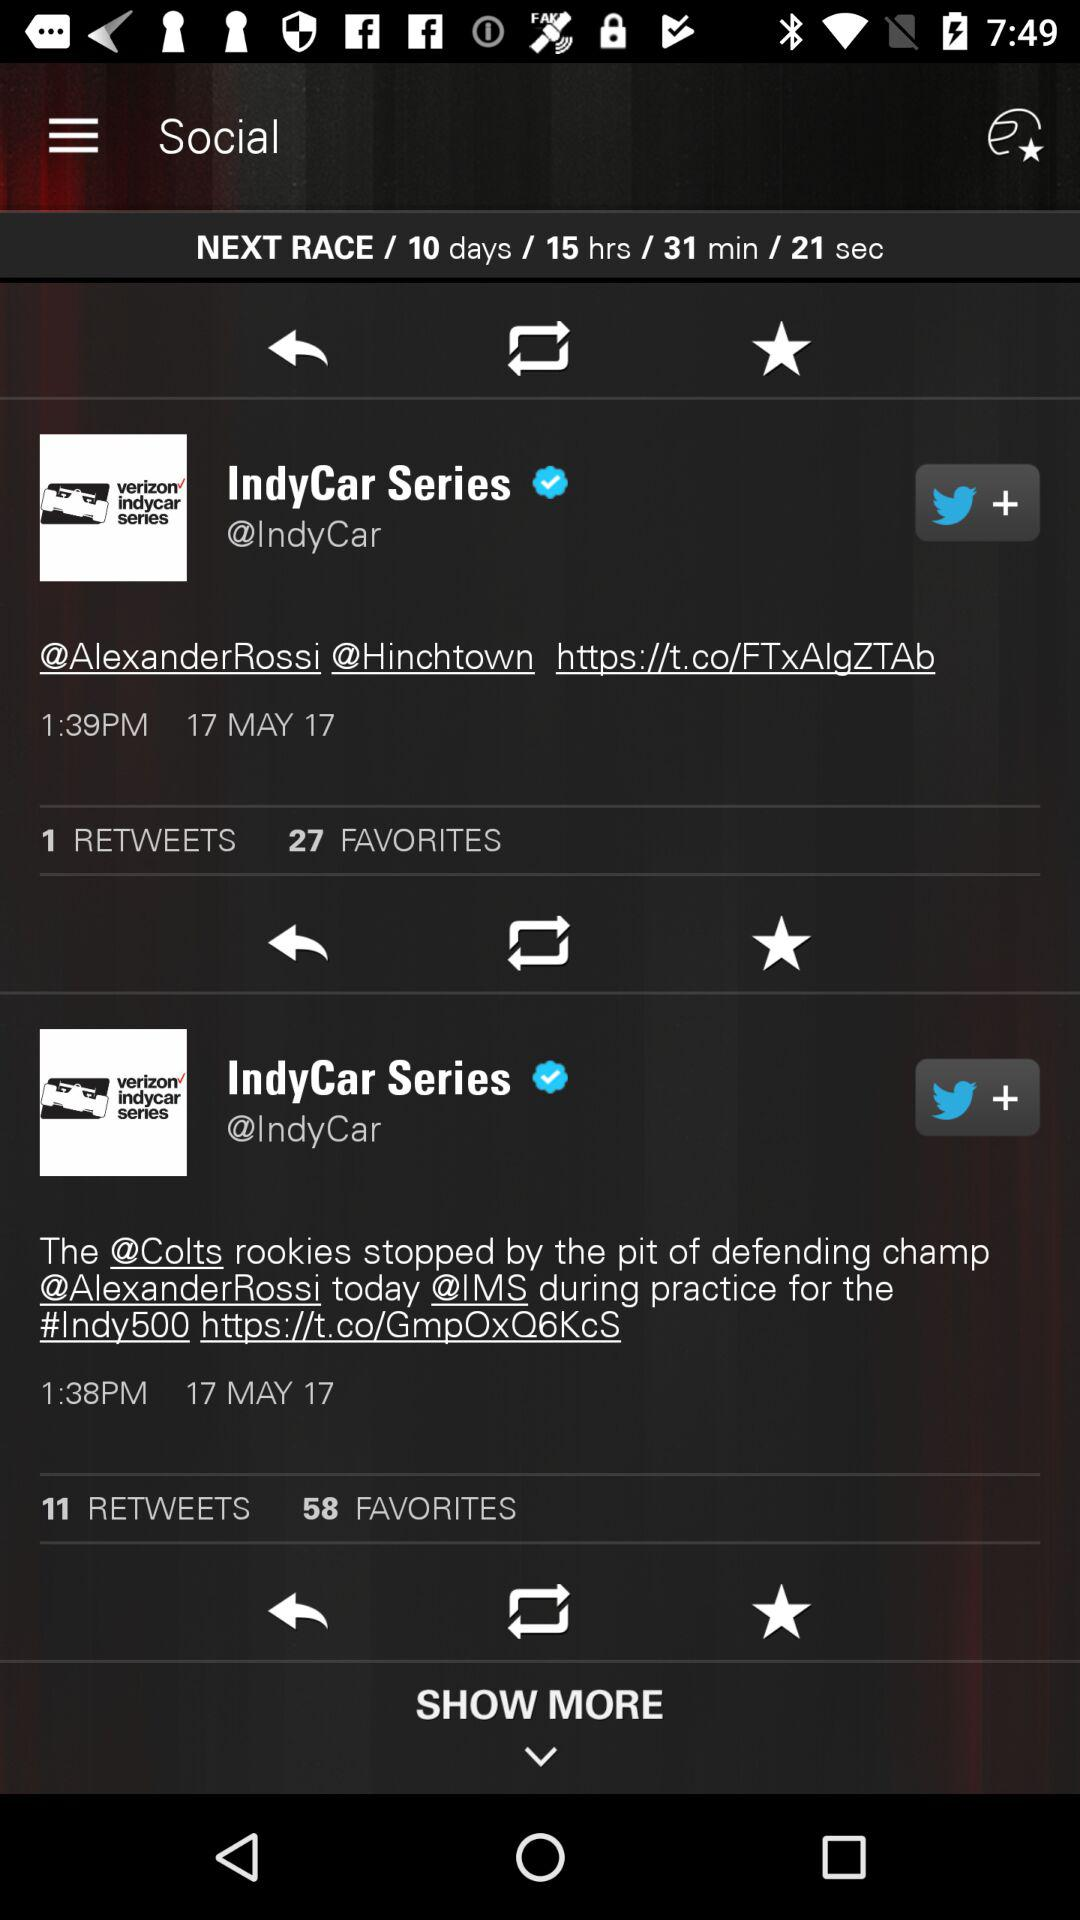How many more favorites does the second tweet have than the first?
Answer the question using a single word or phrase. 31 